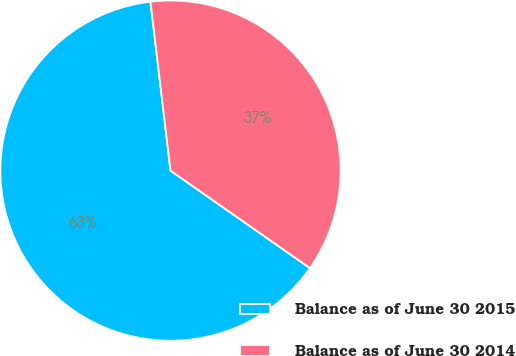<chart> <loc_0><loc_0><loc_500><loc_500><pie_chart><fcel>Balance as of June 30 2015<fcel>Balance as of June 30 2014<nl><fcel>63.41%<fcel>36.59%<nl></chart> 